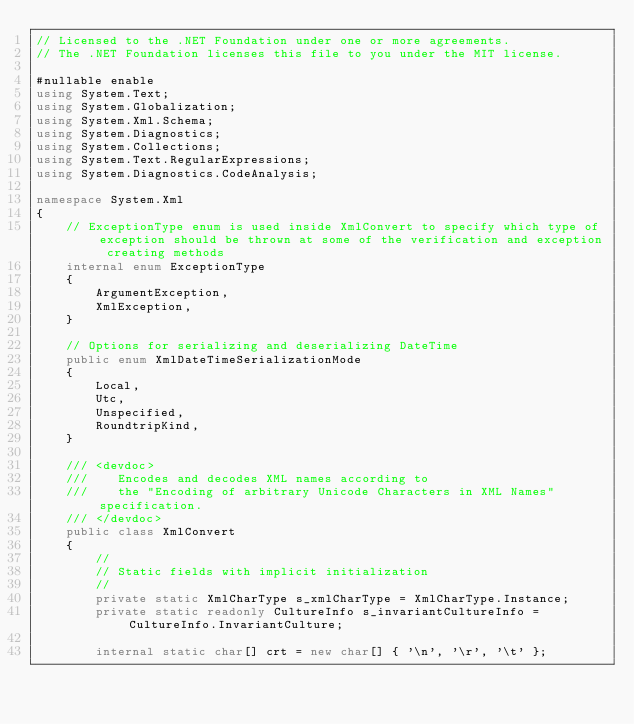<code> <loc_0><loc_0><loc_500><loc_500><_C#_>// Licensed to the .NET Foundation under one or more agreements.
// The .NET Foundation licenses this file to you under the MIT license.

#nullable enable
using System.Text;
using System.Globalization;
using System.Xml.Schema;
using System.Diagnostics;
using System.Collections;
using System.Text.RegularExpressions;
using System.Diagnostics.CodeAnalysis;

namespace System.Xml
{
    // ExceptionType enum is used inside XmlConvert to specify which type of exception should be thrown at some of the verification and exception creating methods
    internal enum ExceptionType
    {
        ArgumentException,
        XmlException,
    }

    // Options for serializing and deserializing DateTime
    public enum XmlDateTimeSerializationMode
    {
        Local,
        Utc,
        Unspecified,
        RoundtripKind,
    }

    /// <devdoc>
    ///    Encodes and decodes XML names according to
    ///    the "Encoding of arbitrary Unicode Characters in XML Names" specification.
    /// </devdoc>
    public class XmlConvert
    {
        //
        // Static fields with implicit initialization
        //
        private static XmlCharType s_xmlCharType = XmlCharType.Instance;
        private static readonly CultureInfo s_invariantCultureInfo = CultureInfo.InvariantCulture;

        internal static char[] crt = new char[] { '\n', '\r', '\t' };
</code> 